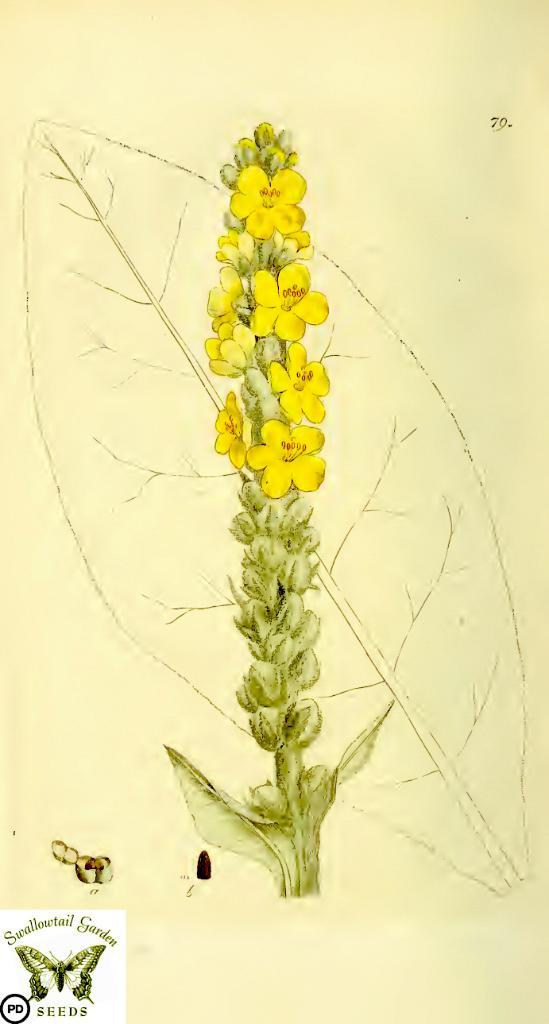What is depicted in the image? There is a drawing of a plant in the image. What color is the plant in the drawing? The plant is green in color. What other elements are present in the drawing? There are flowers in the drawing, which are yellow in color, and there is a leaf. What type of liquid can be seen dripping from the canvas in the image? There is no canvas or liquid present in the image; it features a drawing of a plant with flowers and a leaf. 